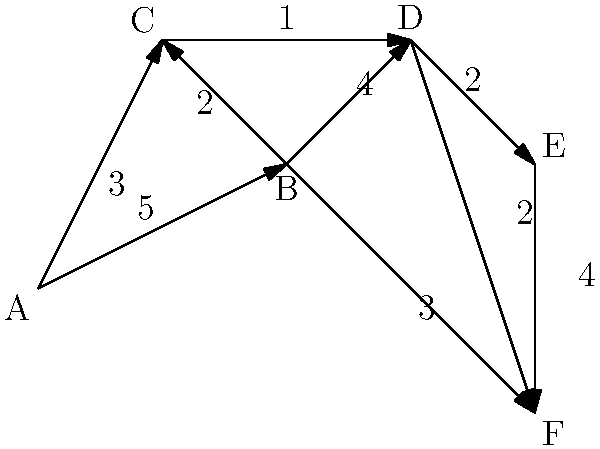As a competitive swimmer, you're designing a new training facility with multiple pools. The network flow diagram represents water flow between different pools, where nodes are pools and edges are pipes with flow capacities (in thousands of liters per hour). What is the maximum flow from pool A to pool F? To find the maximum flow from A to F, we'll use the Ford-Fulkerson algorithm:

1. Initialize flow to 0.
2. Find an augmenting path from A to F:
   a) A → B → F (min capacity: 3)
   Flow = 3, Residual network updated.

3. Find another augmenting path:
   a) A → C → D → F (min capacity: 1)
   Flow = 3 + 1 = 4, Residual network updated.

4. Find another augmenting path:
   a) A → B → D → F (min capacity: 1)
   Flow = 4 + 1 = 5, Residual network updated.

5. Find another augmenting path:
   a) A → B → D → E → F (min capacity: 1)
   Flow = 5 + 1 = 6, Residual network updated.

6. No more augmenting paths exist.

Therefore, the maximum flow from A to F is 6 thousand liters per hour.
Answer: 6 thousand liters per hour 